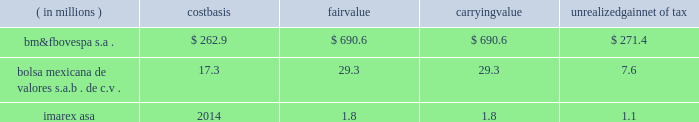Subject to fluctuation and , consequently , the amount realized in the subsequent sale of an investment may differ significantly from its current reported value .
Fluctuations in the market price of a security may result from perceived changes in the underlying economic characteristics of the issuer , the relative price of alternative investments and general market conditions .
The table below summarizes equity investments that are subject to equity price fluctuations at december 31 , 2012 .
Equity investments are included in other assets in our consolidated balance sheets .
( in millions ) carrying unrealized net of tax .
We do not currently hedge against equity price risk .
Equity investments are assessed for other-than- temporary impairment on a quarterly basis. .
In 2012 what was the ratio of the bm&fbovespa s.a . fair value to the cost basis? 
Computations: (690.6 + 262.9)
Answer: 953.5. 